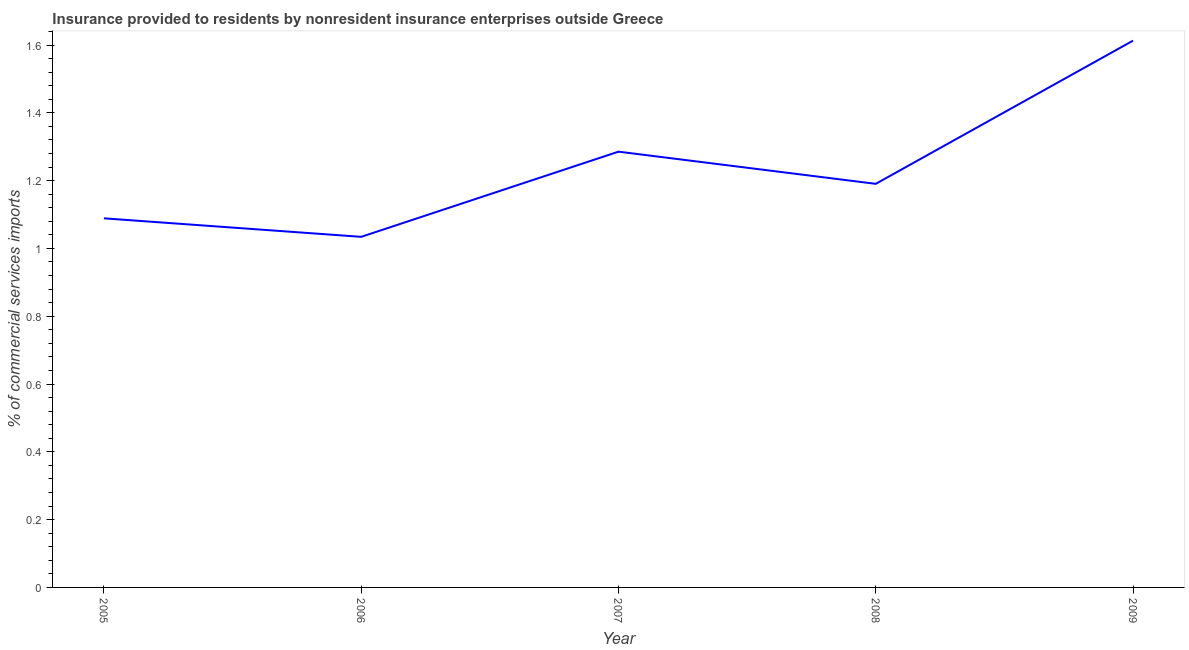What is the insurance provided by non-residents in 2005?
Give a very brief answer. 1.09. Across all years, what is the maximum insurance provided by non-residents?
Your response must be concise. 1.61. Across all years, what is the minimum insurance provided by non-residents?
Offer a very short reply. 1.03. In which year was the insurance provided by non-residents maximum?
Provide a short and direct response. 2009. In which year was the insurance provided by non-residents minimum?
Make the answer very short. 2006. What is the sum of the insurance provided by non-residents?
Your answer should be very brief. 6.21. What is the difference between the insurance provided by non-residents in 2005 and 2007?
Provide a succinct answer. -0.2. What is the average insurance provided by non-residents per year?
Offer a very short reply. 1.24. What is the median insurance provided by non-residents?
Provide a short and direct response. 1.19. In how many years, is the insurance provided by non-residents greater than 0.32 %?
Your response must be concise. 5. Do a majority of the years between 2009 and 2005 (inclusive) have insurance provided by non-residents greater than 0.6000000000000001 %?
Keep it short and to the point. Yes. What is the ratio of the insurance provided by non-residents in 2007 to that in 2009?
Make the answer very short. 0.8. Is the insurance provided by non-residents in 2008 less than that in 2009?
Make the answer very short. Yes. Is the difference between the insurance provided by non-residents in 2006 and 2009 greater than the difference between any two years?
Your answer should be very brief. Yes. What is the difference between the highest and the second highest insurance provided by non-residents?
Your answer should be compact. 0.33. Is the sum of the insurance provided by non-residents in 2008 and 2009 greater than the maximum insurance provided by non-residents across all years?
Make the answer very short. Yes. What is the difference between the highest and the lowest insurance provided by non-residents?
Provide a short and direct response. 0.58. How many lines are there?
Ensure brevity in your answer.  1. How many years are there in the graph?
Offer a terse response. 5. What is the difference between two consecutive major ticks on the Y-axis?
Your response must be concise. 0.2. What is the title of the graph?
Provide a short and direct response. Insurance provided to residents by nonresident insurance enterprises outside Greece. What is the label or title of the X-axis?
Make the answer very short. Year. What is the label or title of the Y-axis?
Offer a terse response. % of commercial services imports. What is the % of commercial services imports in 2005?
Provide a succinct answer. 1.09. What is the % of commercial services imports of 2006?
Your response must be concise. 1.03. What is the % of commercial services imports of 2007?
Your response must be concise. 1.29. What is the % of commercial services imports in 2008?
Provide a short and direct response. 1.19. What is the % of commercial services imports of 2009?
Your answer should be compact. 1.61. What is the difference between the % of commercial services imports in 2005 and 2006?
Make the answer very short. 0.05. What is the difference between the % of commercial services imports in 2005 and 2007?
Ensure brevity in your answer.  -0.2. What is the difference between the % of commercial services imports in 2005 and 2008?
Provide a succinct answer. -0.1. What is the difference between the % of commercial services imports in 2005 and 2009?
Keep it short and to the point. -0.52. What is the difference between the % of commercial services imports in 2006 and 2007?
Provide a short and direct response. -0.25. What is the difference between the % of commercial services imports in 2006 and 2008?
Offer a very short reply. -0.16. What is the difference between the % of commercial services imports in 2006 and 2009?
Offer a very short reply. -0.58. What is the difference between the % of commercial services imports in 2007 and 2008?
Offer a very short reply. 0.09. What is the difference between the % of commercial services imports in 2007 and 2009?
Ensure brevity in your answer.  -0.33. What is the difference between the % of commercial services imports in 2008 and 2009?
Make the answer very short. -0.42. What is the ratio of the % of commercial services imports in 2005 to that in 2006?
Provide a short and direct response. 1.05. What is the ratio of the % of commercial services imports in 2005 to that in 2007?
Provide a short and direct response. 0.85. What is the ratio of the % of commercial services imports in 2005 to that in 2008?
Ensure brevity in your answer.  0.92. What is the ratio of the % of commercial services imports in 2005 to that in 2009?
Make the answer very short. 0.68. What is the ratio of the % of commercial services imports in 2006 to that in 2007?
Your response must be concise. 0.81. What is the ratio of the % of commercial services imports in 2006 to that in 2008?
Give a very brief answer. 0.87. What is the ratio of the % of commercial services imports in 2006 to that in 2009?
Keep it short and to the point. 0.64. What is the ratio of the % of commercial services imports in 2007 to that in 2008?
Keep it short and to the point. 1.08. What is the ratio of the % of commercial services imports in 2007 to that in 2009?
Offer a very short reply. 0.8. What is the ratio of the % of commercial services imports in 2008 to that in 2009?
Offer a very short reply. 0.74. 